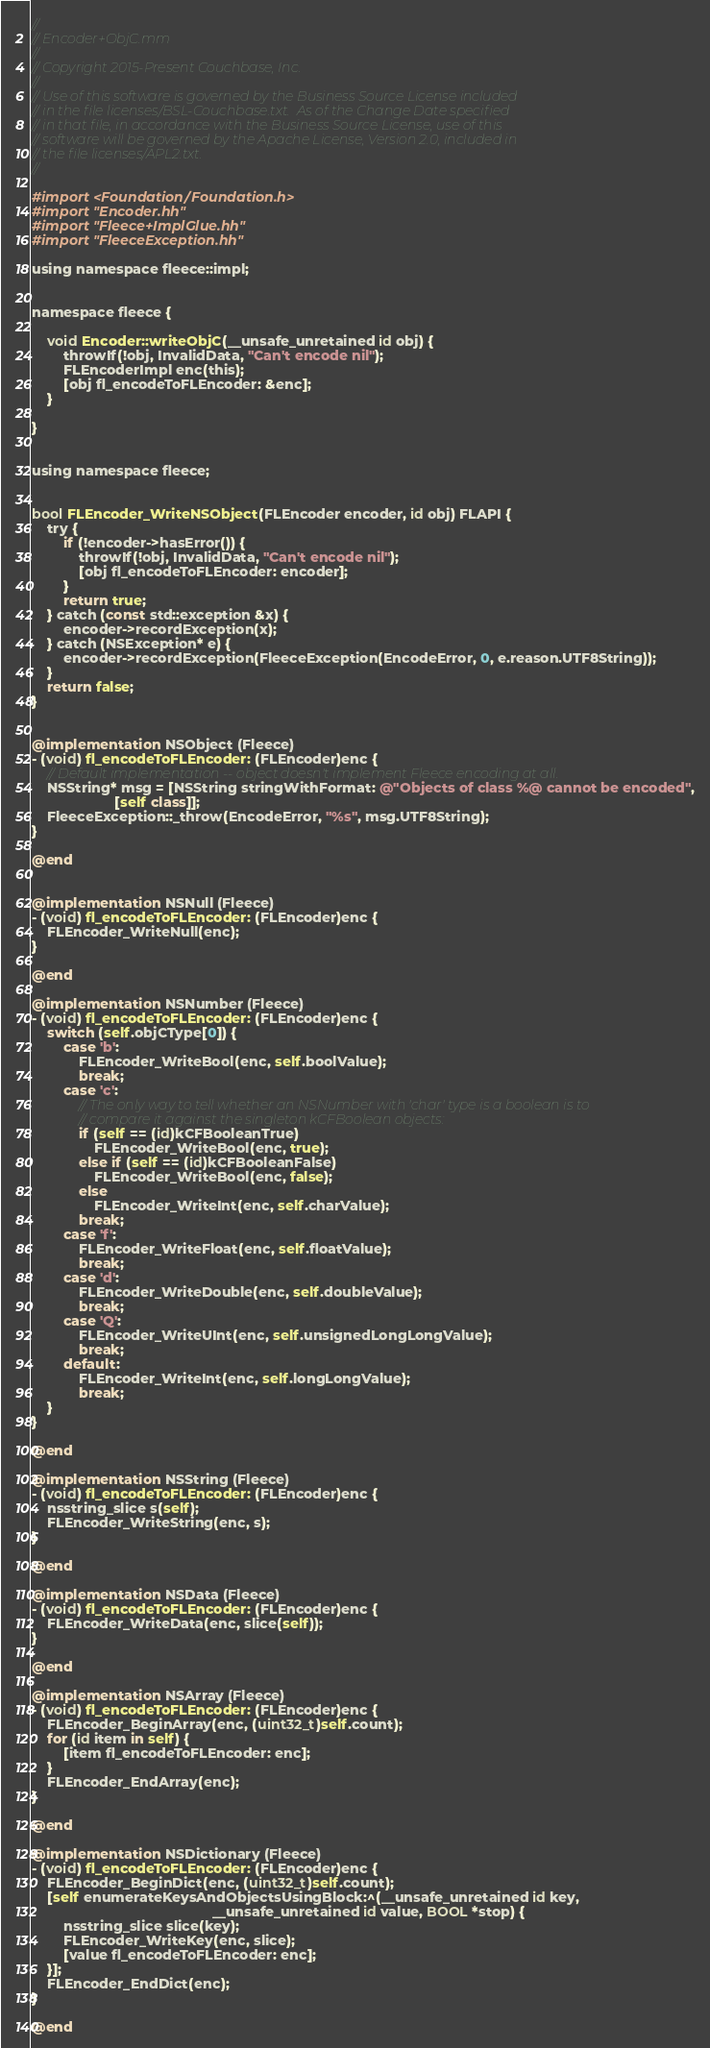<code> <loc_0><loc_0><loc_500><loc_500><_ObjectiveC_>//
// Encoder+ObjC.mm
//
// Copyright 2015-Present Couchbase, Inc.
//
// Use of this software is governed by the Business Source License included
// in the file licenses/BSL-Couchbase.txt.  As of the Change Date specified
// in that file, in accordance with the Business Source License, use of this
// software will be governed by the Apache License, Version 2.0, included in
// the file licenses/APL2.txt.
//

#import <Foundation/Foundation.h>
#import "Encoder.hh"
#import "Fleece+ImplGlue.hh"
#import "FleeceException.hh"

using namespace fleece::impl;


namespace fleece {

    void Encoder::writeObjC(__unsafe_unretained id obj) {
        throwIf(!obj, InvalidData, "Can't encode nil");
        FLEncoderImpl enc(this);
        [obj fl_encodeToFLEncoder: &enc];
    }

}


using namespace fleece;


bool FLEncoder_WriteNSObject(FLEncoder encoder, id obj) FLAPI {
    try {
        if (!encoder->hasError()) {
            throwIf(!obj, InvalidData, "Can't encode nil");
            [obj fl_encodeToFLEncoder: encoder];
        }
        return true;
    } catch (const std::exception &x) {
        encoder->recordException(x);
    } catch (NSException* e) {
        encoder->recordException(FleeceException(EncodeError, 0, e.reason.UTF8String));
    }
    return false;
}


@implementation NSObject (Fleece)
- (void) fl_encodeToFLEncoder: (FLEncoder)enc {
    // Default implementation -- object doesn't implement Fleece encoding at all.
    NSString* msg = [NSString stringWithFormat: @"Objects of class %@ cannot be encoded",
                     [self class]];
    FleeceException::_throw(EncodeError, "%s", msg.UTF8String);
}

@end


@implementation NSNull (Fleece)
- (void) fl_encodeToFLEncoder: (FLEncoder)enc {
    FLEncoder_WriteNull(enc);
}

@end

@implementation NSNumber (Fleece)
- (void) fl_encodeToFLEncoder: (FLEncoder)enc {
    switch (self.objCType[0]) {
        case 'b':
            FLEncoder_WriteBool(enc, self.boolValue);
            break;
        case 'c':
            // The only way to tell whether an NSNumber with 'char' type is a boolean is to
            // compare it against the singleton kCFBoolean objects:
            if (self == (id)kCFBooleanTrue)
                FLEncoder_WriteBool(enc, true);
            else if (self == (id)kCFBooleanFalse)
                FLEncoder_WriteBool(enc, false);
            else
                FLEncoder_WriteInt(enc, self.charValue);
            break;
        case 'f':
            FLEncoder_WriteFloat(enc, self.floatValue);
            break;
        case 'd':
            FLEncoder_WriteDouble(enc, self.doubleValue);
            break;
        case 'Q':
            FLEncoder_WriteUInt(enc, self.unsignedLongLongValue);
            break;
        default:
            FLEncoder_WriteInt(enc, self.longLongValue);
            break;
    }
}

@end

@implementation NSString (Fleece)
- (void) fl_encodeToFLEncoder: (FLEncoder)enc {
    nsstring_slice s(self);
    FLEncoder_WriteString(enc, s);
}

@end

@implementation NSData (Fleece)
- (void) fl_encodeToFLEncoder: (FLEncoder)enc {
    FLEncoder_WriteData(enc, slice(self));
}

@end

@implementation NSArray (Fleece)
- (void) fl_encodeToFLEncoder: (FLEncoder)enc {
    FLEncoder_BeginArray(enc, (uint32_t)self.count);
    for (id item in self) {
        [item fl_encodeToFLEncoder: enc];
    }
    FLEncoder_EndArray(enc);
}

@end

@implementation NSDictionary (Fleece)
- (void) fl_encodeToFLEncoder: (FLEncoder)enc {
    FLEncoder_BeginDict(enc, (uint32_t)self.count);
    [self enumerateKeysAndObjectsUsingBlock:^(__unsafe_unretained id key,
                                              __unsafe_unretained id value, BOOL *stop) {
        nsstring_slice slice(key);
        FLEncoder_WriteKey(enc, slice);
        [value fl_encodeToFLEncoder: enc];
    }];
    FLEncoder_EndDict(enc);
}

@end
</code> 